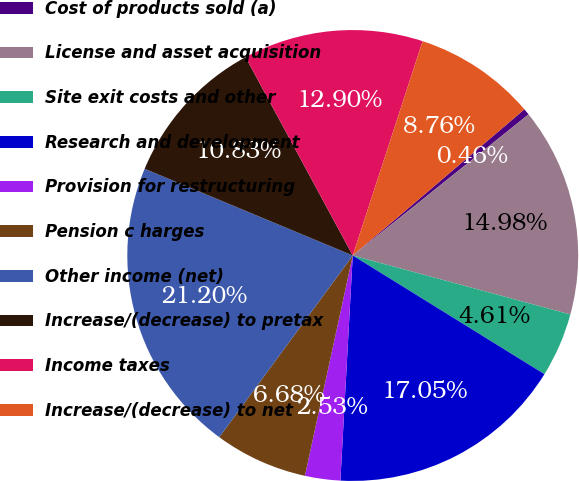Convert chart. <chart><loc_0><loc_0><loc_500><loc_500><pie_chart><fcel>Cost of products sold (a)<fcel>License and asset acquisition<fcel>Site exit costs and other<fcel>Research and development<fcel>Provision for restructuring<fcel>Pension c harges<fcel>Other income (net)<fcel>Increase/(decrease) to pretax<fcel>Income taxes<fcel>Increase/(decrease) to net<nl><fcel>0.46%<fcel>14.98%<fcel>4.61%<fcel>17.05%<fcel>2.53%<fcel>6.68%<fcel>21.2%<fcel>10.83%<fcel>12.9%<fcel>8.76%<nl></chart> 